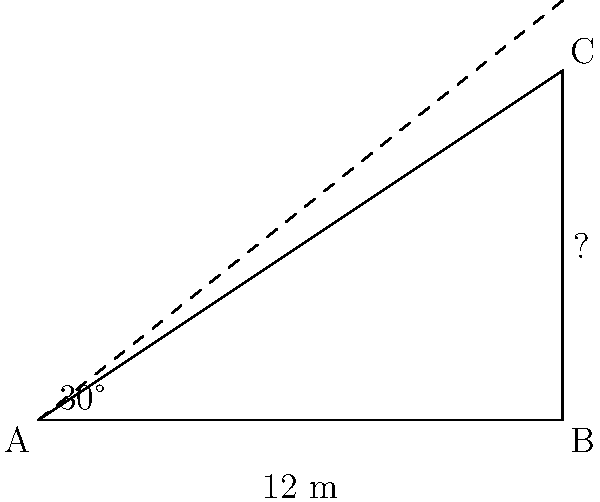As you stand outside a magnificent cathedral, you're inspired to write a song about its towering spire. To capture the awe-inspiring height in your lyrics, you decide to calculate it. You measure the distance from where you're standing to the base of the spire to be 12 meters. The angle of elevation to the top of the spire is 30°. Using trigonometric ratios, calculate the height of the church spire to the nearest meter. Let's approach this step-by-step:

1) We can model this situation as a right-angled triangle, where:
   - The base of the triangle is the distance from you to the base of the spire (12 meters)
   - The height of the triangle is the height of the spire (what we're trying to find)
   - The angle at the base of the triangle is 30°

2) In this right-angled triangle, we know:
   - The adjacent side (12 meters)
   - The angle (30°)
   - We need to find the opposite side (height of the spire)

3) The trigonometric ratio that relates the opposite side to the adjacent side is tangent:

   $\tan \theta = \frac{\text{opposite}}{\text{adjacent}}$

4) Let's call the height of the spire $h$. We can write:

   $\tan 30° = \frac{h}{12}$

5) To solve for $h$, we multiply both sides by 12:

   $12 \tan 30° = h$

6) Now, we need to calculate this:
   $\tan 30° = \frac{1}{\sqrt{3}} \approx 0.577$

7) So:
   $h = 12 * 0.577 = 6.924$ meters

8) Rounding to the nearest meter:
   $h \approx 7$ meters
Answer: 7 meters 